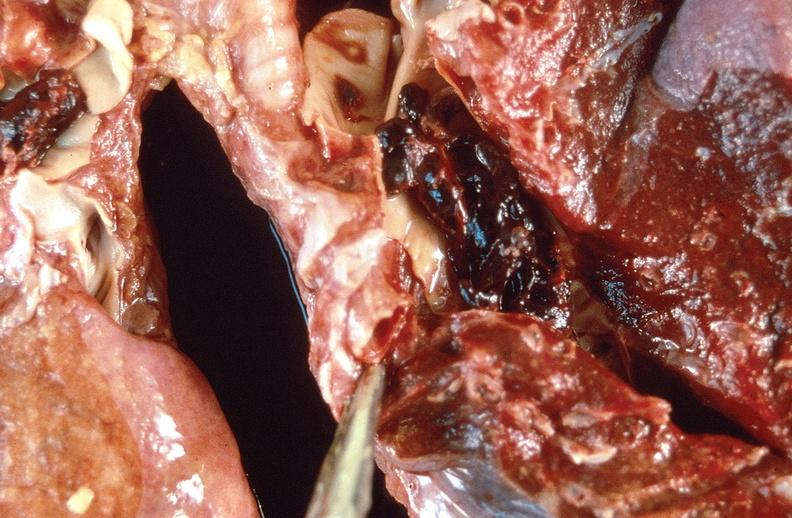s respiratory present?
Answer the question using a single word or phrase. Yes 